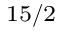Convert formula to latex. <formula><loc_0><loc_0><loc_500><loc_500>_ { 1 5 / 2 }</formula> 